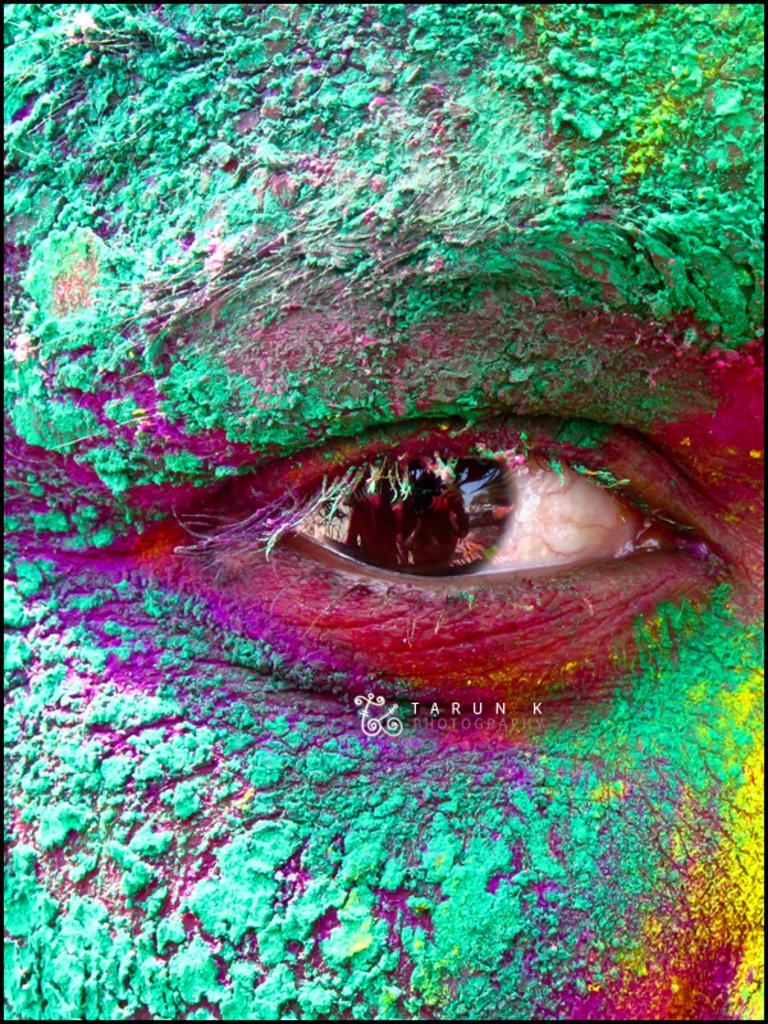How would you summarize this image in a sentence or two? In this image I can see an eye of a person. Here I can see a watermark. I can also see some colors around the eye. 